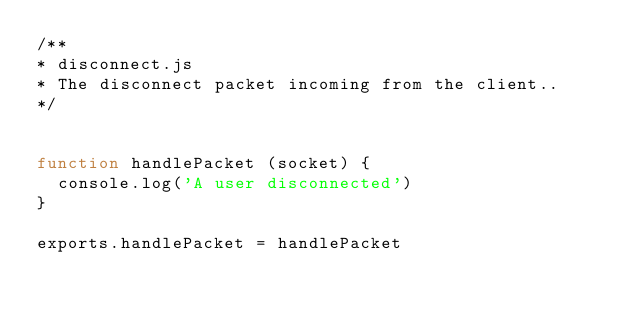Convert code to text. <code><loc_0><loc_0><loc_500><loc_500><_JavaScript_>/**
* disconnect.js
* The disconnect packet incoming from the client..
*/


function handlePacket (socket) {
  console.log('A user disconnected')
}

exports.handlePacket = handlePacket
</code> 